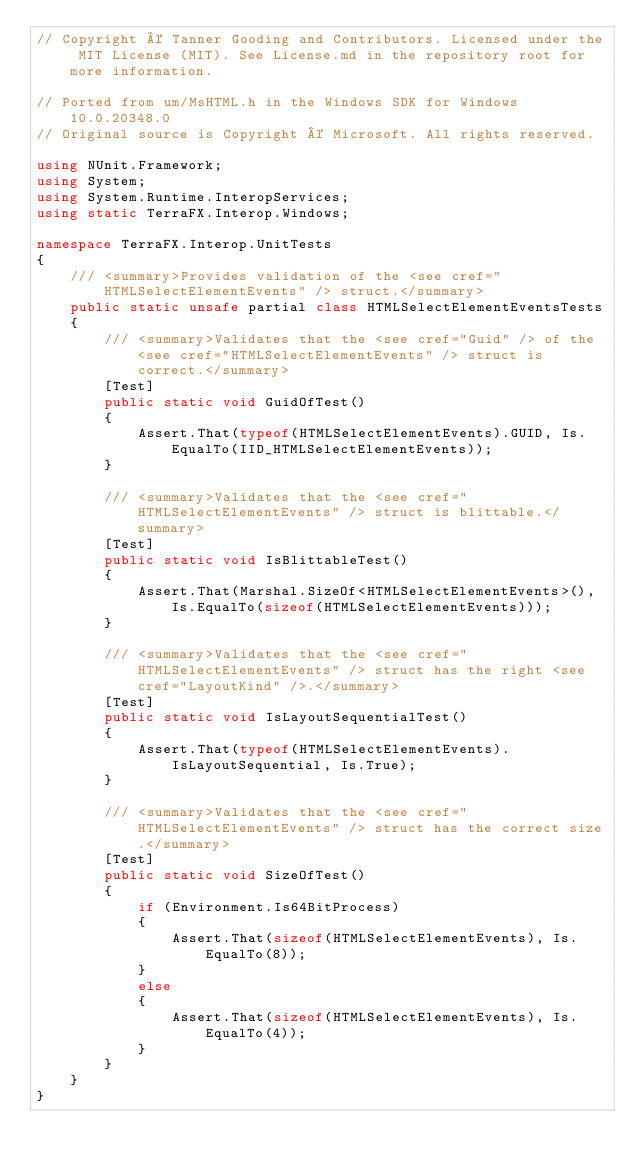<code> <loc_0><loc_0><loc_500><loc_500><_C#_>// Copyright © Tanner Gooding and Contributors. Licensed under the MIT License (MIT). See License.md in the repository root for more information.

// Ported from um/MsHTML.h in the Windows SDK for Windows 10.0.20348.0
// Original source is Copyright © Microsoft. All rights reserved.

using NUnit.Framework;
using System;
using System.Runtime.InteropServices;
using static TerraFX.Interop.Windows;

namespace TerraFX.Interop.UnitTests
{
    /// <summary>Provides validation of the <see cref="HTMLSelectElementEvents" /> struct.</summary>
    public static unsafe partial class HTMLSelectElementEventsTests
    {
        /// <summary>Validates that the <see cref="Guid" /> of the <see cref="HTMLSelectElementEvents" /> struct is correct.</summary>
        [Test]
        public static void GuidOfTest()
        {
            Assert.That(typeof(HTMLSelectElementEvents).GUID, Is.EqualTo(IID_HTMLSelectElementEvents));
        }

        /// <summary>Validates that the <see cref="HTMLSelectElementEvents" /> struct is blittable.</summary>
        [Test]
        public static void IsBlittableTest()
        {
            Assert.That(Marshal.SizeOf<HTMLSelectElementEvents>(), Is.EqualTo(sizeof(HTMLSelectElementEvents)));
        }

        /// <summary>Validates that the <see cref="HTMLSelectElementEvents" /> struct has the right <see cref="LayoutKind" />.</summary>
        [Test]
        public static void IsLayoutSequentialTest()
        {
            Assert.That(typeof(HTMLSelectElementEvents).IsLayoutSequential, Is.True);
        }

        /// <summary>Validates that the <see cref="HTMLSelectElementEvents" /> struct has the correct size.</summary>
        [Test]
        public static void SizeOfTest()
        {
            if (Environment.Is64BitProcess)
            {
                Assert.That(sizeof(HTMLSelectElementEvents), Is.EqualTo(8));
            }
            else
            {
                Assert.That(sizeof(HTMLSelectElementEvents), Is.EqualTo(4));
            }
        }
    }
}
</code> 